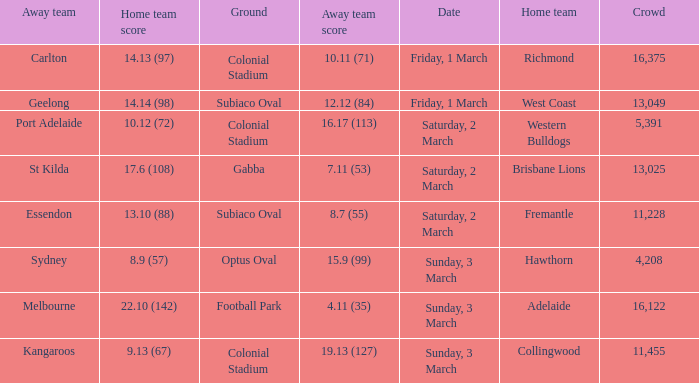Who is the away team when the home team scored 17.6 (108)? St Kilda. 